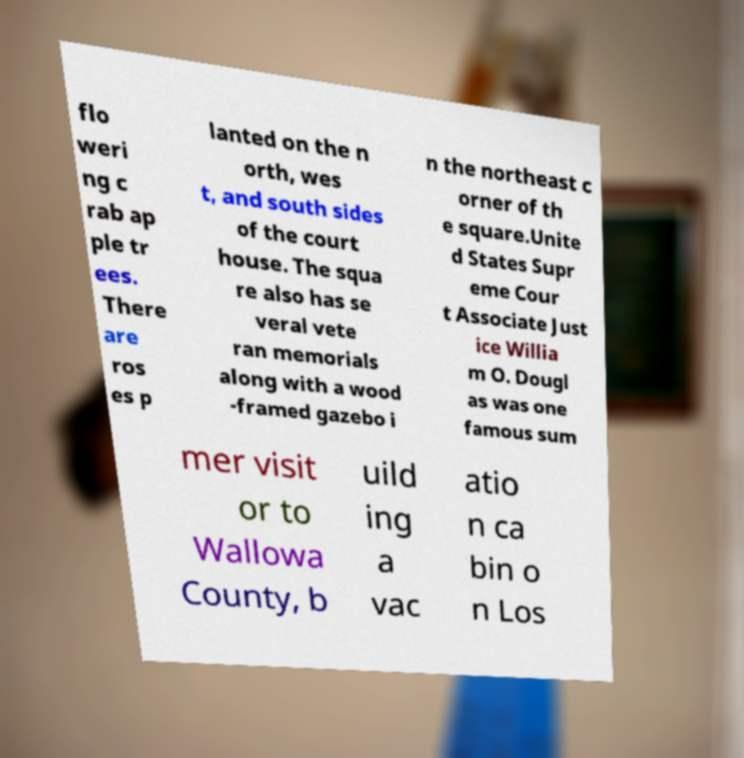Could you assist in decoding the text presented in this image and type it out clearly? flo weri ng c rab ap ple tr ees. There are ros es p lanted on the n orth, wes t, and south sides of the court house. The squa re also has se veral vete ran memorials along with a wood -framed gazebo i n the northeast c orner of th e square.Unite d States Supr eme Cour t Associate Just ice Willia m O. Dougl as was one famous sum mer visit or to Wallowa County, b uild ing a vac atio n ca bin o n Los 